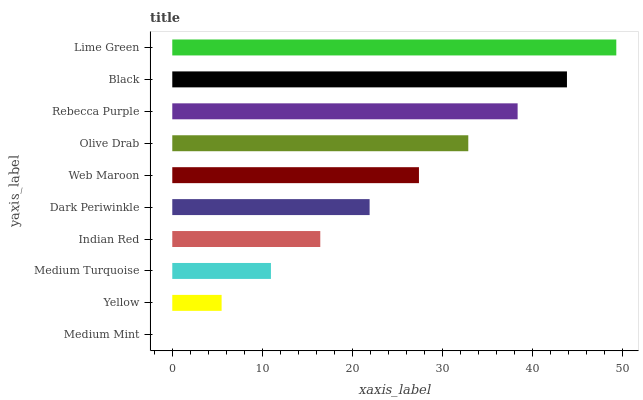Is Medium Mint the minimum?
Answer yes or no. Yes. Is Lime Green the maximum?
Answer yes or no. Yes. Is Yellow the minimum?
Answer yes or no. No. Is Yellow the maximum?
Answer yes or no. No. Is Yellow greater than Medium Mint?
Answer yes or no. Yes. Is Medium Mint less than Yellow?
Answer yes or no. Yes. Is Medium Mint greater than Yellow?
Answer yes or no. No. Is Yellow less than Medium Mint?
Answer yes or no. No. Is Web Maroon the high median?
Answer yes or no. Yes. Is Dark Periwinkle the low median?
Answer yes or no. Yes. Is Black the high median?
Answer yes or no. No. Is Olive Drab the low median?
Answer yes or no. No. 